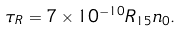Convert formula to latex. <formula><loc_0><loc_0><loc_500><loc_500>\tau _ { R } = 7 \times 1 0 ^ { - 1 0 } R _ { 1 5 } n _ { 0 } .</formula> 